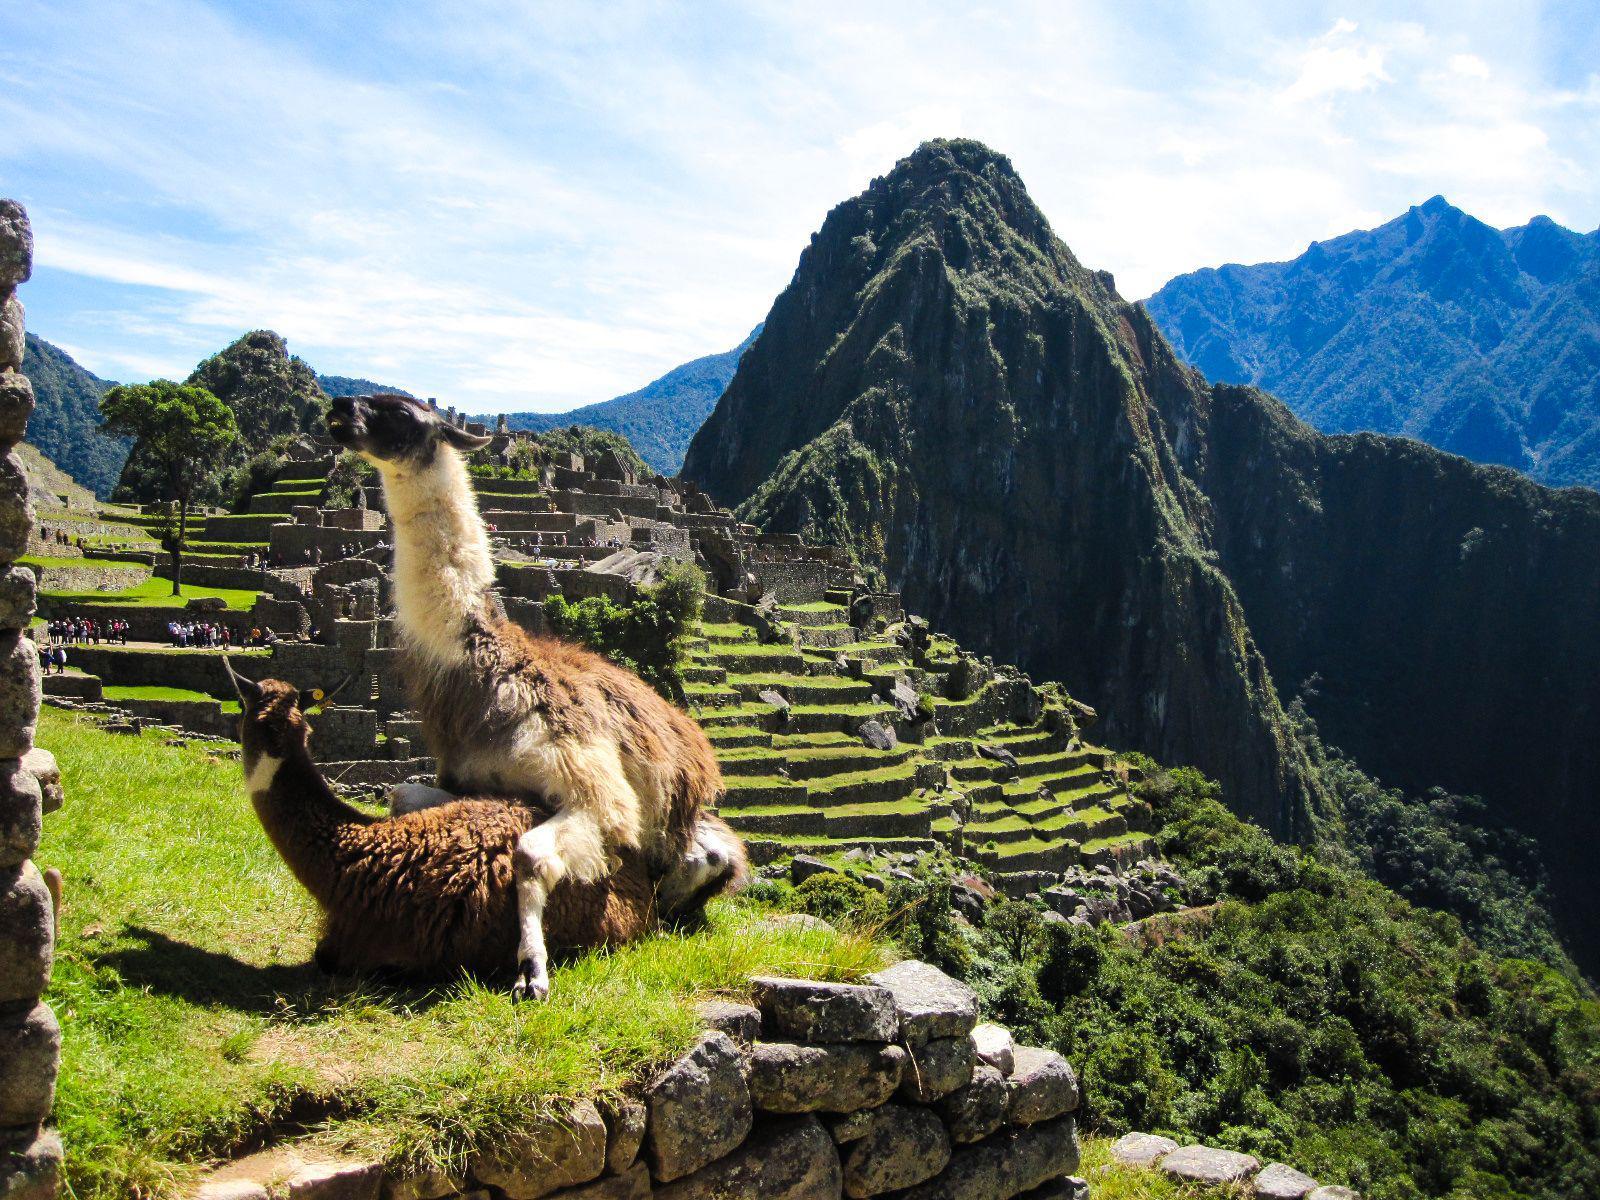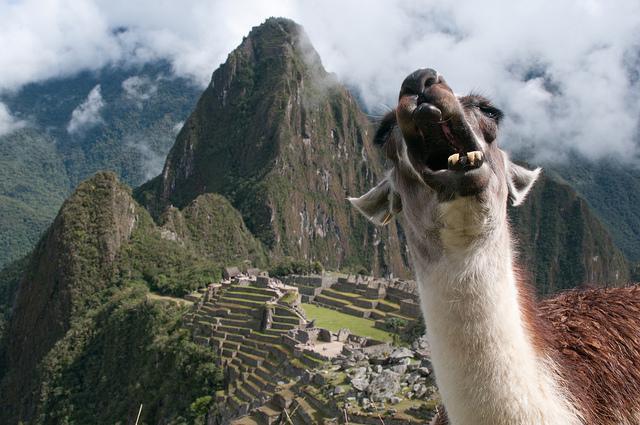The first image is the image on the left, the second image is the image on the right. Analyze the images presented: Is the assertion "In at least one image there is a single white and brown lama with their neck extended and a green hill and one stone mountain peak to the right of them." valid? Answer yes or no. Yes. The first image is the image on the left, the second image is the image on the right. Given the left and right images, does the statement "The left image features a llama with head angled forward, standing in the foreground on the left, with mountains and mazelike structures behind it." hold true? Answer yes or no. No. 